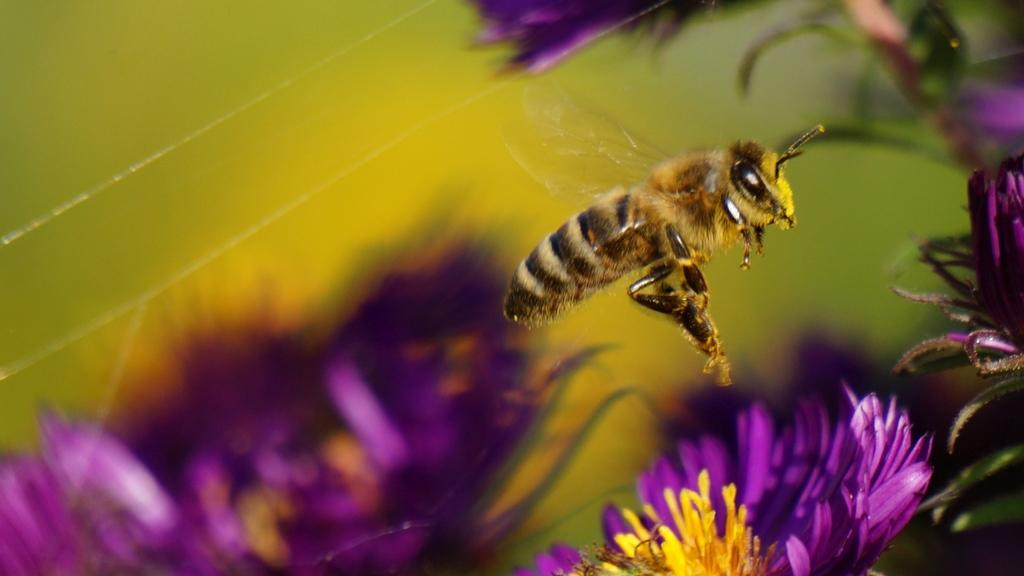What type of insect can be seen in the picture? There is a honey bee in the picture. What is the honey bee interacting with in the picture? The honey bee is interacting with flowers in the picture. Can you describe the background of the image? The background of the image is blurry. Reasoning: Let's think step by step by step in order to produce the conversation. We start by identifying the main subject in the image, which is the honey bee. Then, we expand the conversation to include the honey bee's interaction with flowers, which is a natural behavior for honey bees. Finally, we describe the background of the image, noting that it is blurry. Each question is designed to elicit a specific detail about the image that is known from the provided facts. Absurd Question/Answer: What type of dust can be seen on the giraffe's back in the image? There is no giraffe present in the image, and therefore no dust on its back can be observed. 